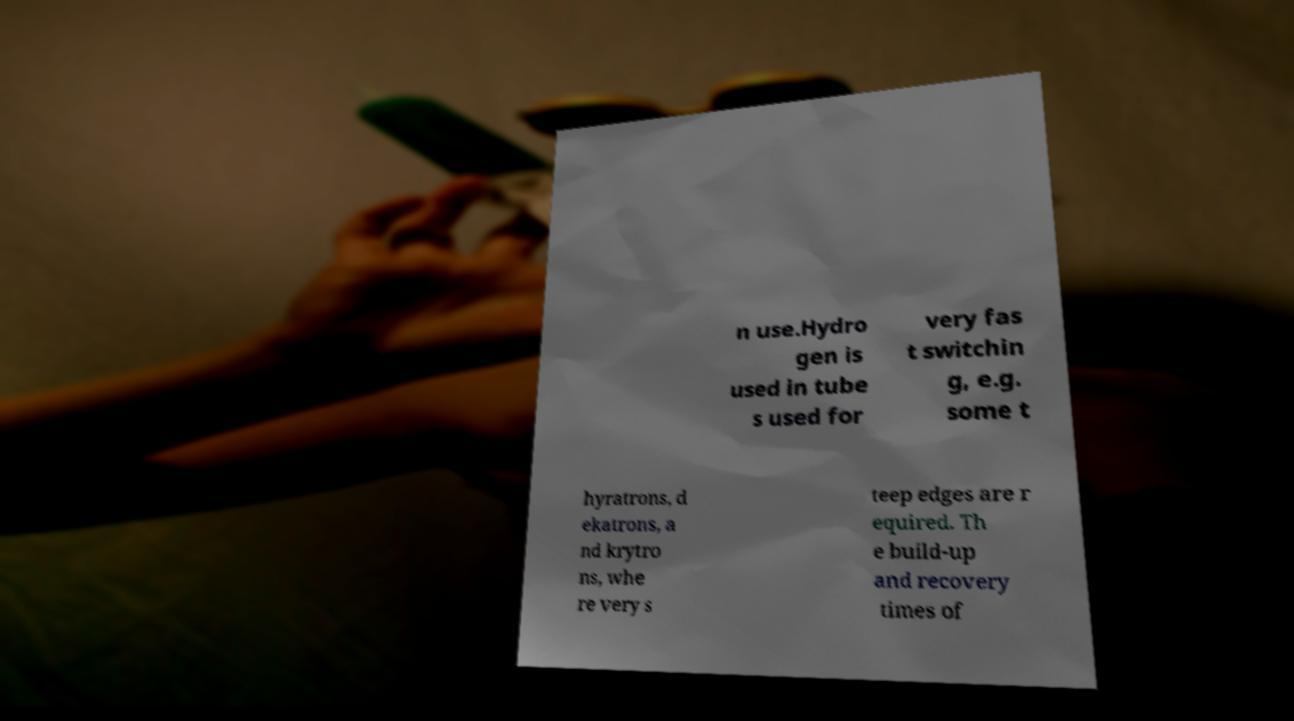Could you extract and type out the text from this image? n use.Hydro gen is used in tube s used for very fas t switchin g, e.g. some t hyratrons, d ekatrons, a nd krytro ns, whe re very s teep edges are r equired. Th e build-up and recovery times of 